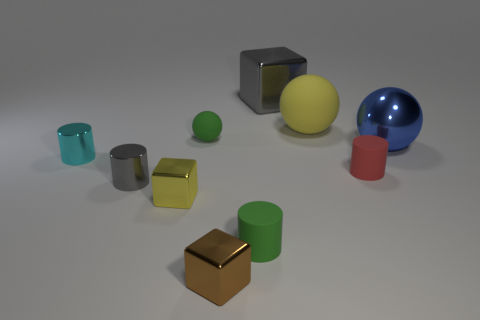Subtract all cyan metal cylinders. How many cylinders are left? 3 Subtract 1 cylinders. How many cylinders are left? 3 Subtract all purple cylinders. Subtract all gray cubes. How many cylinders are left? 4 Subtract all cylinders. How many objects are left? 6 Add 3 brown metallic things. How many brown metallic things are left? 4 Add 1 small balls. How many small balls exist? 2 Subtract 0 purple cubes. How many objects are left? 10 Subtract all tiny purple objects. Subtract all red matte cylinders. How many objects are left? 9 